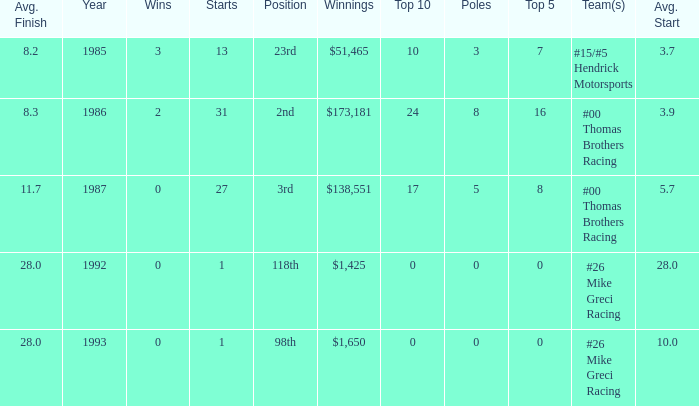What team was Bodine in when he had an average finish of 8.3? #00 Thomas Brothers Racing. 